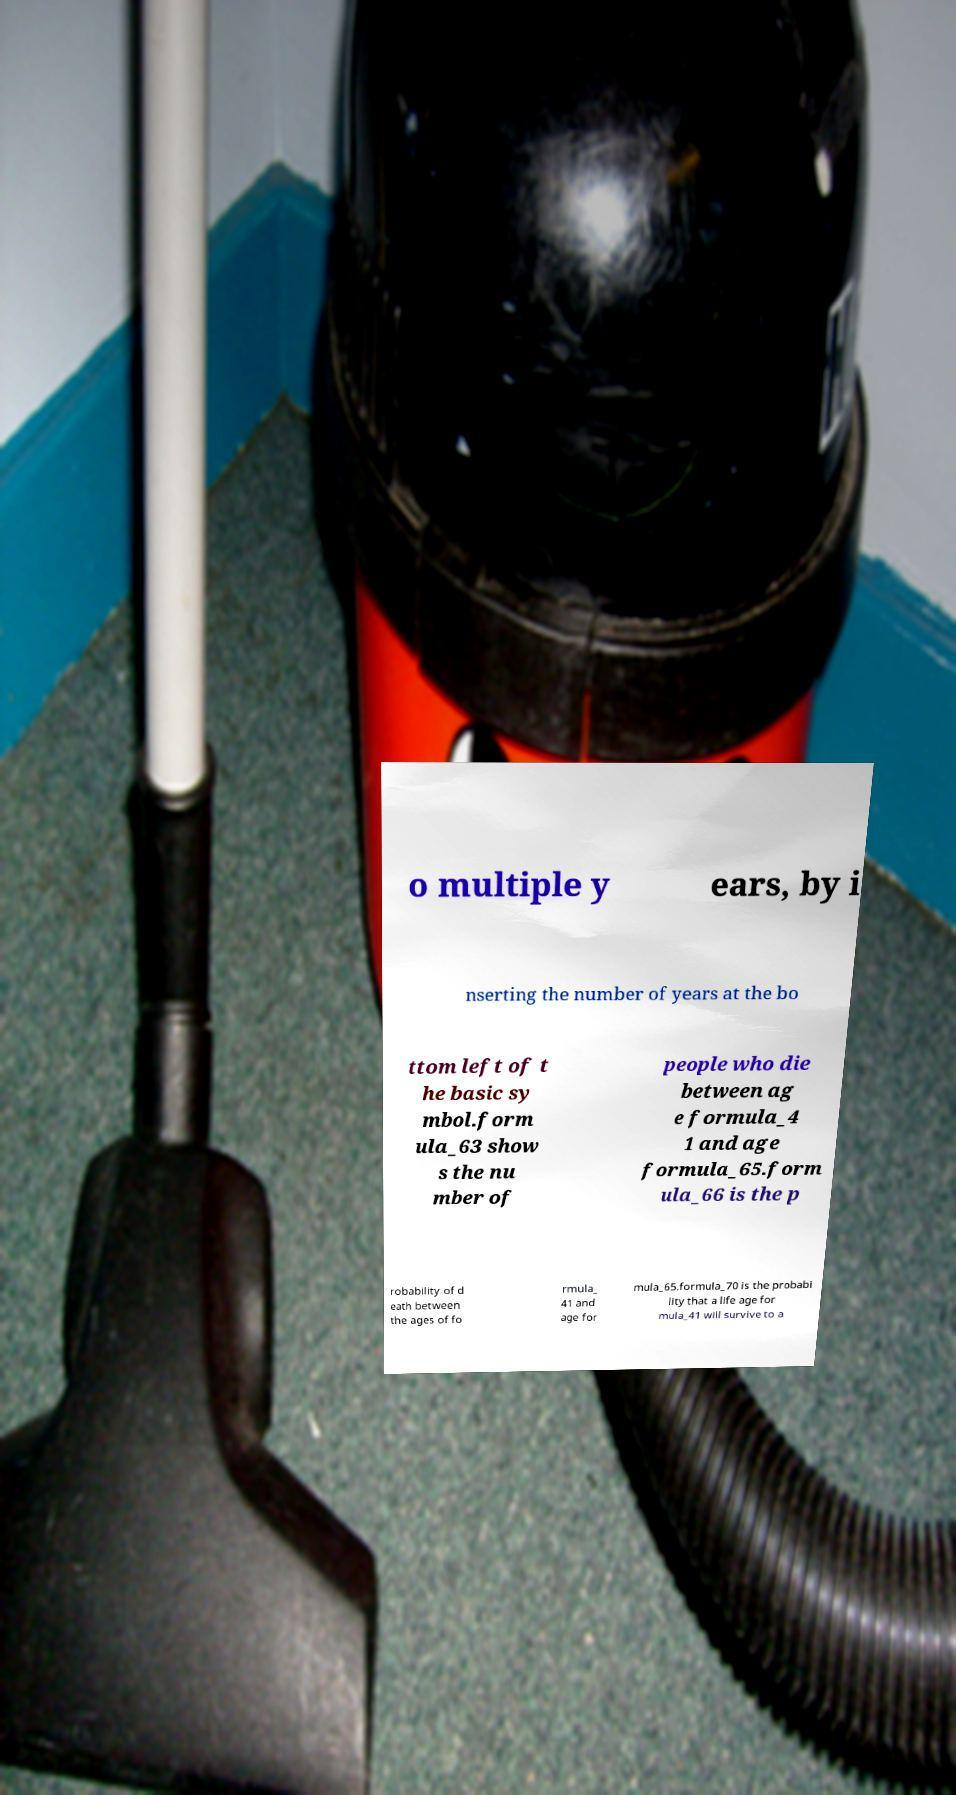I need the written content from this picture converted into text. Can you do that? o multiple y ears, by i nserting the number of years at the bo ttom left of t he basic sy mbol.form ula_63 show s the nu mber of people who die between ag e formula_4 1 and age formula_65.form ula_66 is the p robability of d eath between the ages of fo rmula_ 41 and age for mula_65.formula_70 is the probabi lity that a life age for mula_41 will survive to a 